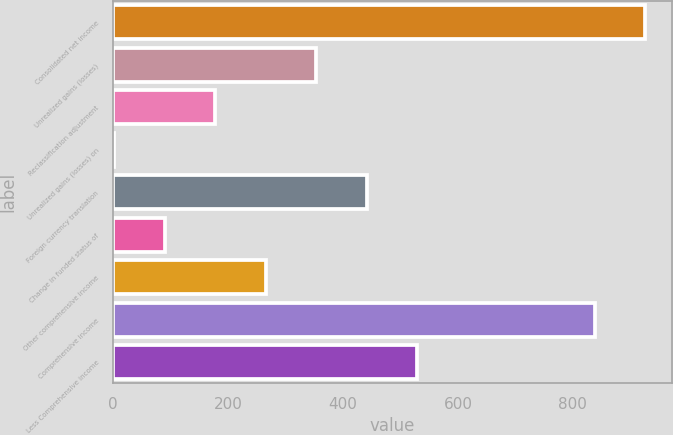Convert chart to OTSL. <chart><loc_0><loc_0><loc_500><loc_500><bar_chart><fcel>Consolidated net income<fcel>Unrealized gains (losses)<fcel>Reclassification adjustment<fcel>Unrealized gains (losses) on<fcel>Foreign currency translation<fcel>Change in funded status of<fcel>Other comprehensive income<fcel>Comprehensive income<fcel>Less Comprehensive income<nl><fcel>925.9<fcel>353.6<fcel>177.8<fcel>2<fcel>441.5<fcel>89.9<fcel>265.7<fcel>838<fcel>529.4<nl></chart> 